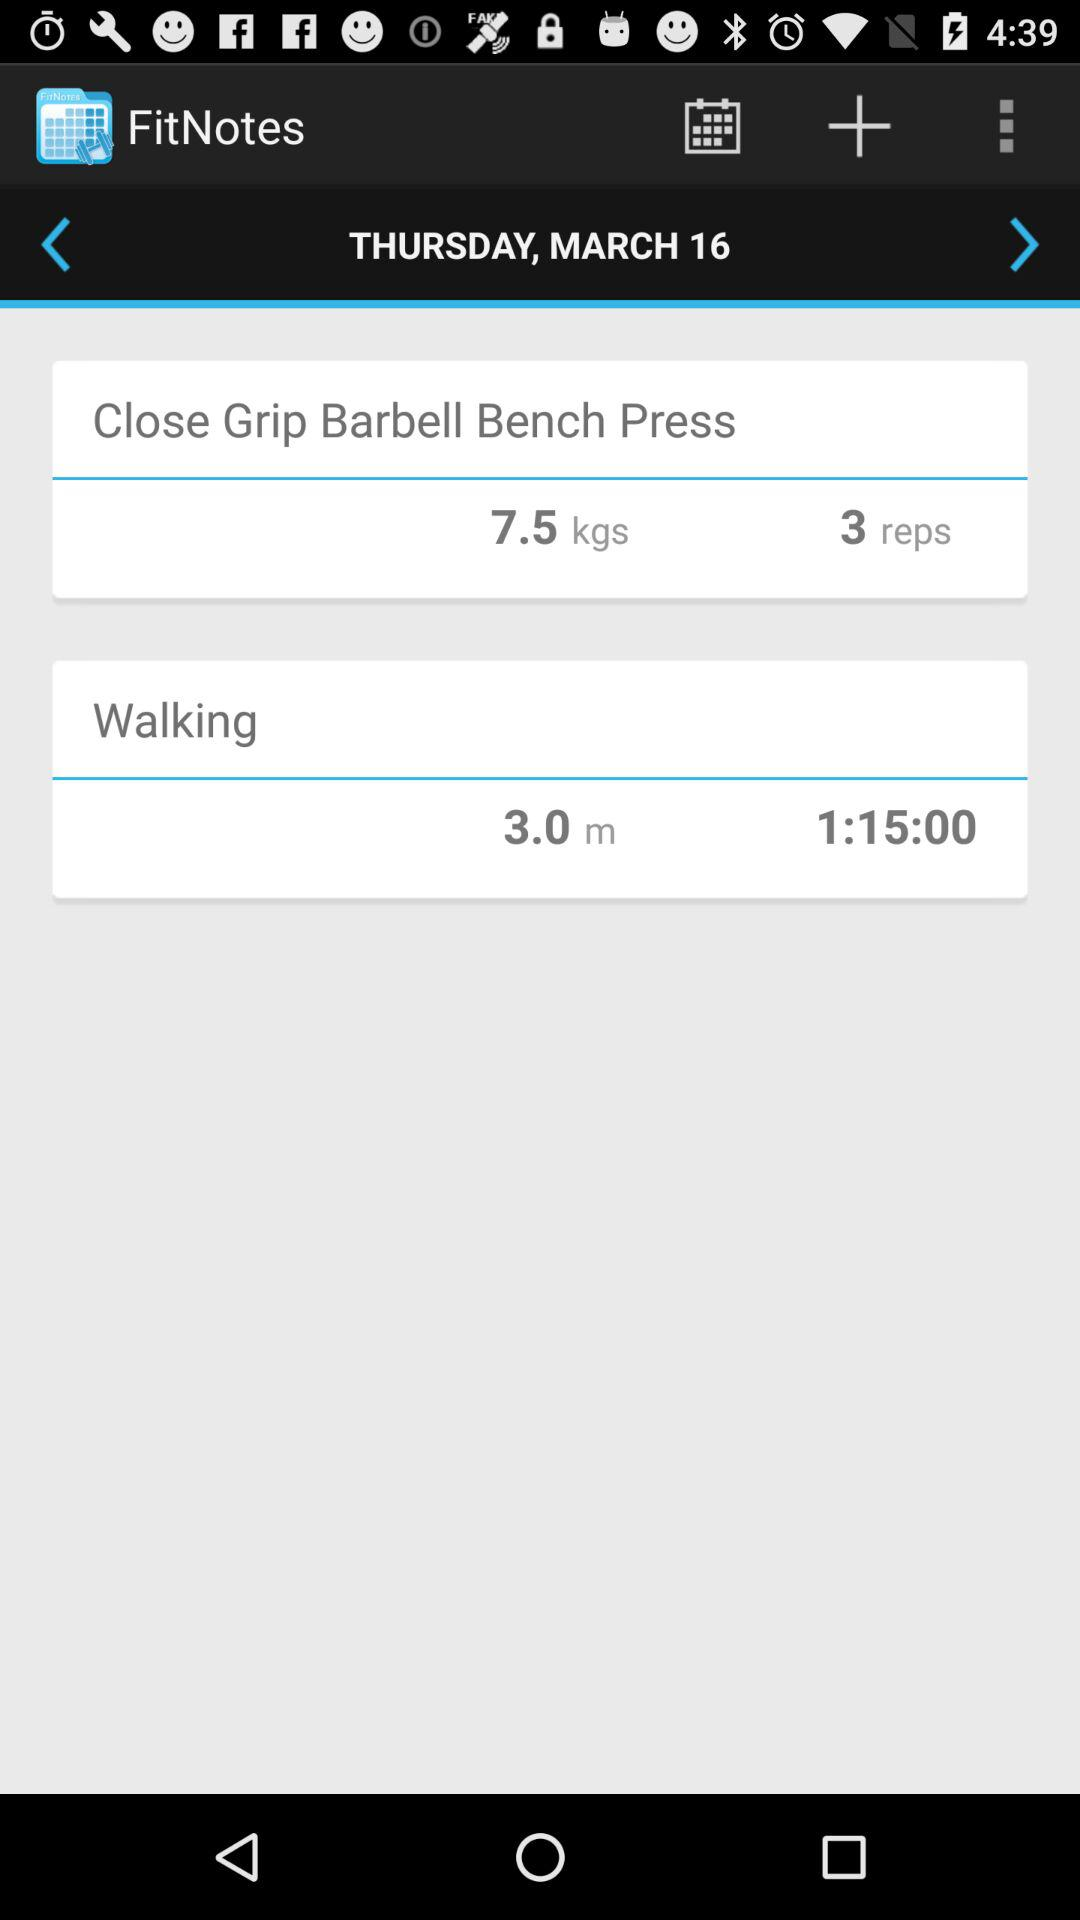What is the weight in "Close Grip Barbell Bench Press"? The weight is 7.5 kg. 